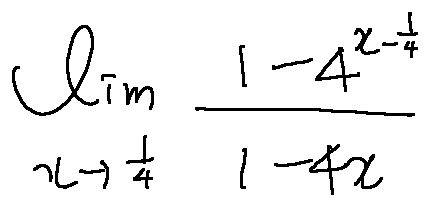Convert formula to latex. <formula><loc_0><loc_0><loc_500><loc_500>\lim \lim i t s _ { x \rightarrow \frac { 1 } { 4 } } \frac { 1 - 4 ^ { x - \frac { 1 } { 4 } } } { 1 - 4 x }</formula> 